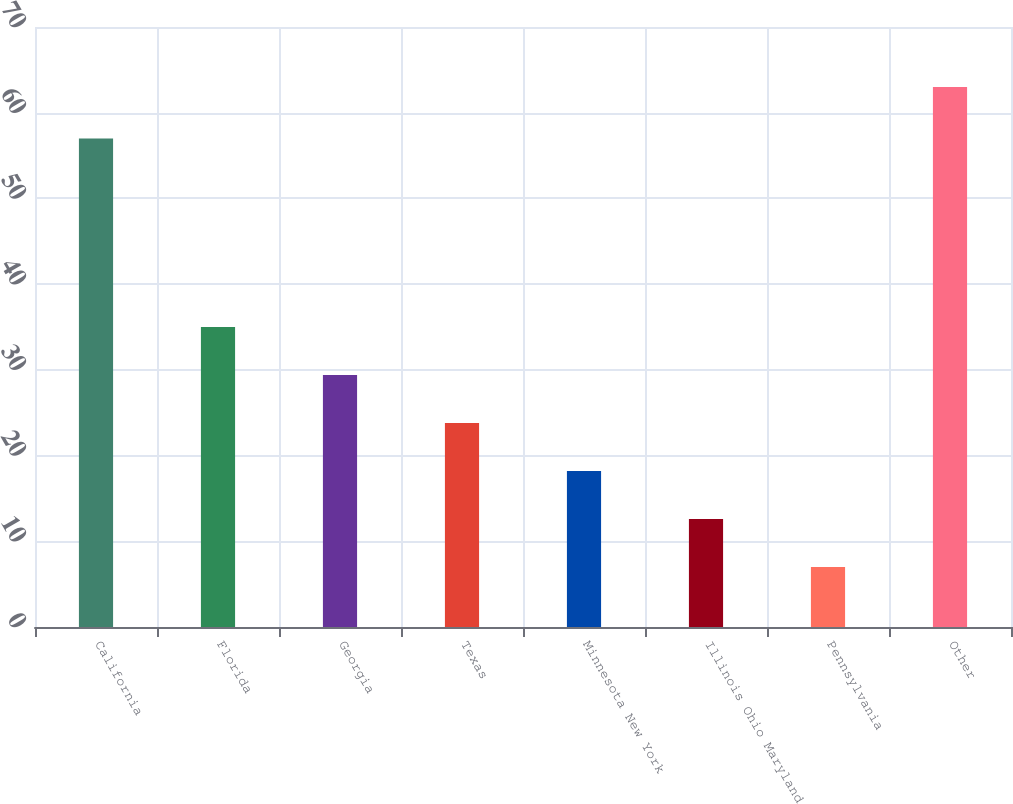Convert chart to OTSL. <chart><loc_0><loc_0><loc_500><loc_500><bar_chart><fcel>California<fcel>Florida<fcel>Georgia<fcel>Texas<fcel>Minnesota New York<fcel>Illinois Ohio Maryland<fcel>Pennsylvania<fcel>Other<nl><fcel>57<fcel>35<fcel>29.4<fcel>23.8<fcel>18.2<fcel>12.6<fcel>7<fcel>63<nl></chart> 